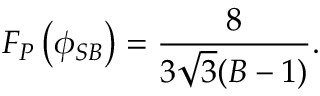<formula> <loc_0><loc_0><loc_500><loc_500>F _ { P } \left ( \phi _ { S B } \right ) = \frac { 8 } { 3 \sqrt { 3 } ( B - 1 ) } .</formula> 